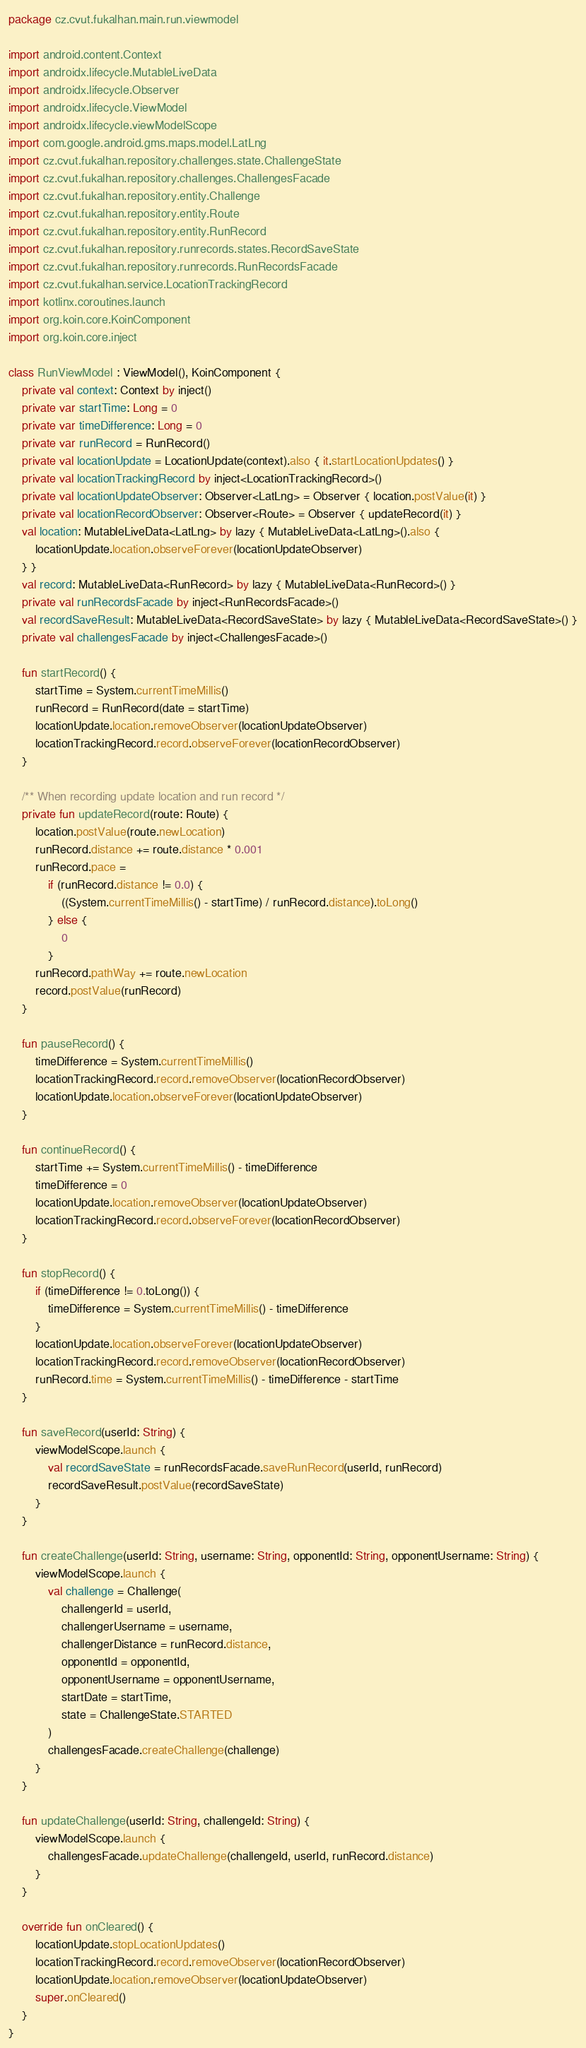<code> <loc_0><loc_0><loc_500><loc_500><_Kotlin_>package cz.cvut.fukalhan.main.run.viewmodel

import android.content.Context
import androidx.lifecycle.MutableLiveData
import androidx.lifecycle.Observer
import androidx.lifecycle.ViewModel
import androidx.lifecycle.viewModelScope
import com.google.android.gms.maps.model.LatLng
import cz.cvut.fukalhan.repository.challenges.state.ChallengeState
import cz.cvut.fukalhan.repository.challenges.ChallengesFacade
import cz.cvut.fukalhan.repository.entity.Challenge
import cz.cvut.fukalhan.repository.entity.Route
import cz.cvut.fukalhan.repository.entity.RunRecord
import cz.cvut.fukalhan.repository.runrecords.states.RecordSaveState
import cz.cvut.fukalhan.repository.runrecords.RunRecordsFacade
import cz.cvut.fukalhan.service.LocationTrackingRecord
import kotlinx.coroutines.launch
import org.koin.core.KoinComponent
import org.koin.core.inject

class RunViewModel : ViewModel(), KoinComponent {
    private val context: Context by inject()
    private var startTime: Long = 0
    private var timeDifference: Long = 0
    private var runRecord = RunRecord()
    private val locationUpdate = LocationUpdate(context).also { it.startLocationUpdates() }
    private val locationTrackingRecord by inject<LocationTrackingRecord>()
    private val locationUpdateObserver: Observer<LatLng> = Observer { location.postValue(it) }
    private val locationRecordObserver: Observer<Route> = Observer { updateRecord(it) }
    val location: MutableLiveData<LatLng> by lazy { MutableLiveData<LatLng>().also {
        locationUpdate.location.observeForever(locationUpdateObserver)
    } }
    val record: MutableLiveData<RunRecord> by lazy { MutableLiveData<RunRecord>() }
    private val runRecordsFacade by inject<RunRecordsFacade>()
    val recordSaveResult: MutableLiveData<RecordSaveState> by lazy { MutableLiveData<RecordSaveState>() }
    private val challengesFacade by inject<ChallengesFacade>()

    fun startRecord() {
        startTime = System.currentTimeMillis()
        runRecord = RunRecord(date = startTime)
        locationUpdate.location.removeObserver(locationUpdateObserver)
        locationTrackingRecord.record.observeForever(locationRecordObserver)
    }

    /** When recording update location and run record */
    private fun updateRecord(route: Route) {
        location.postValue(route.newLocation)
        runRecord.distance += route.distance * 0.001
        runRecord.pace =
            if (runRecord.distance != 0.0) {
                ((System.currentTimeMillis() - startTime) / runRecord.distance).toLong()
            } else {
                0
            }
        runRecord.pathWay += route.newLocation
        record.postValue(runRecord)
    }

    fun pauseRecord() {
        timeDifference = System.currentTimeMillis()
        locationTrackingRecord.record.removeObserver(locationRecordObserver)
        locationUpdate.location.observeForever(locationUpdateObserver)
    }

    fun continueRecord() {
        startTime += System.currentTimeMillis() - timeDifference
        timeDifference = 0
        locationUpdate.location.removeObserver(locationUpdateObserver)
        locationTrackingRecord.record.observeForever(locationRecordObserver)
    }

    fun stopRecord() {
        if (timeDifference != 0.toLong()) {
            timeDifference = System.currentTimeMillis() - timeDifference
        }
        locationUpdate.location.observeForever(locationUpdateObserver)
        locationTrackingRecord.record.removeObserver(locationRecordObserver)
        runRecord.time = System.currentTimeMillis() - timeDifference - startTime
    }

    fun saveRecord(userId: String) {
        viewModelScope.launch {
            val recordSaveState = runRecordsFacade.saveRunRecord(userId, runRecord)
            recordSaveResult.postValue(recordSaveState)
        }
    }

    fun createChallenge(userId: String, username: String, opponentId: String, opponentUsername: String) {
        viewModelScope.launch {
            val challenge = Challenge(
                challengerId = userId,
                challengerUsername = username,
                challengerDistance = runRecord.distance,
                opponentId = opponentId,
                opponentUsername = opponentUsername,
                startDate = startTime,
                state = ChallengeState.STARTED
            )
            challengesFacade.createChallenge(challenge)
        }
    }

    fun updateChallenge(userId: String, challengeId: String) {
        viewModelScope.launch {
            challengesFacade.updateChallenge(challengeId, userId, runRecord.distance)
        }
    }

    override fun onCleared() {
        locationUpdate.stopLocationUpdates()
        locationTrackingRecord.record.removeObserver(locationRecordObserver)
        locationUpdate.location.removeObserver(locationUpdateObserver)
        super.onCleared()
    }
}</code> 